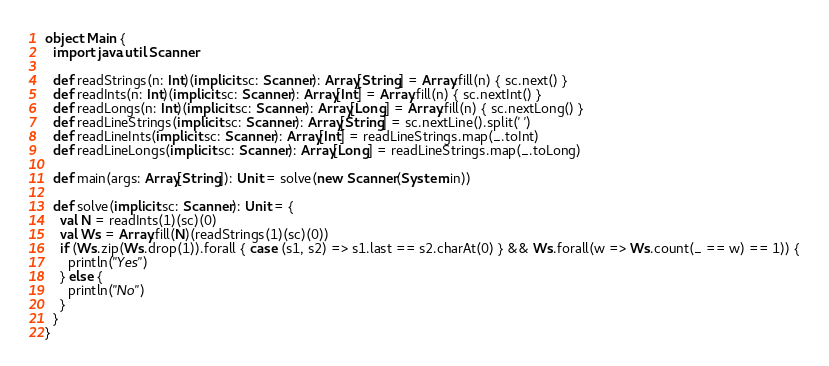<code> <loc_0><loc_0><loc_500><loc_500><_Scala_>object Main {
  import java.util.Scanner

  def readStrings(n: Int)(implicit sc: Scanner): Array[String] = Array.fill(n) { sc.next() }
  def readInts(n: Int)(implicit sc: Scanner): Array[Int] = Array.fill(n) { sc.nextInt() }
  def readLongs(n: Int)(implicit sc: Scanner): Array[Long] = Array.fill(n) { sc.nextLong() }
  def readLineStrings(implicit sc: Scanner): Array[String] = sc.nextLine().split(' ')
  def readLineInts(implicit sc: Scanner): Array[Int] = readLineStrings.map(_.toInt)
  def readLineLongs(implicit sc: Scanner): Array[Long] = readLineStrings.map(_.toLong)

  def main(args: Array[String]): Unit = solve(new Scanner(System.in))

  def solve(implicit sc: Scanner): Unit = {
    val N = readInts(1)(sc)(0)
    val Ws = Array.fill(N)(readStrings(1)(sc)(0))
    if (Ws.zip(Ws.drop(1)).forall { case (s1, s2) => s1.last == s2.charAt(0) } && Ws.forall(w => Ws.count(_ == w) == 1)) {
      println("Yes")
    } else {
      println("No")
    }
  }
}
</code> 